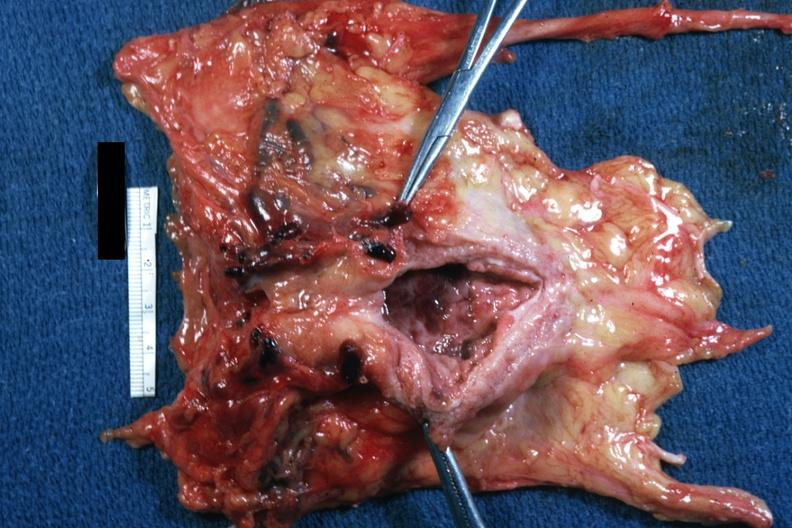s periprostatic vein thrombi present?
Answer the question using a single word or phrase. Yes 